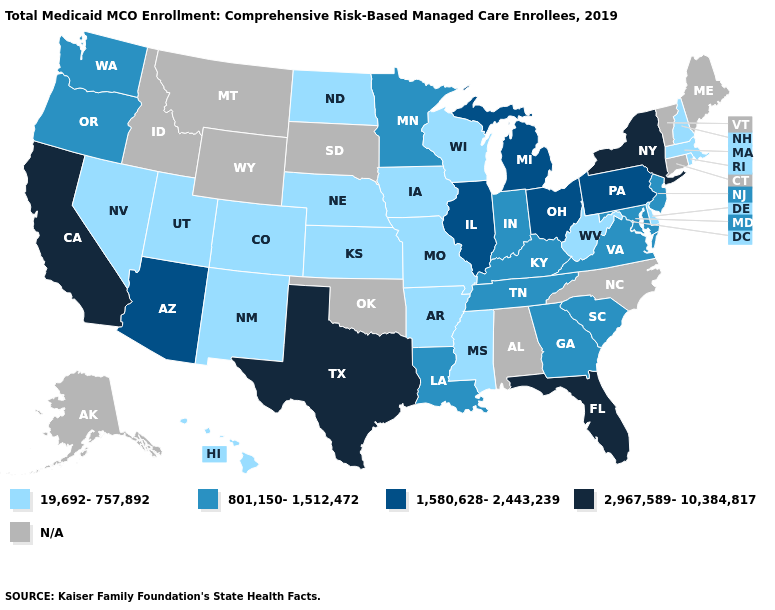Does the map have missing data?
Answer briefly. Yes. Among the states that border Montana , which have the highest value?
Answer briefly. North Dakota. Name the states that have a value in the range N/A?
Give a very brief answer. Alabama, Alaska, Connecticut, Idaho, Maine, Montana, North Carolina, Oklahoma, South Dakota, Vermont, Wyoming. Which states have the lowest value in the Northeast?
Keep it brief. Massachusetts, New Hampshire, Rhode Island. What is the value of Maine?
Concise answer only. N/A. Among the states that border Pennsylvania , which have the lowest value?
Concise answer only. Delaware, West Virginia. Does the first symbol in the legend represent the smallest category?
Be succinct. Yes. Does Colorado have the highest value in the USA?
Keep it brief. No. Does the first symbol in the legend represent the smallest category?
Short answer required. Yes. What is the highest value in the USA?
Give a very brief answer. 2,967,589-10,384,817. How many symbols are there in the legend?
Be succinct. 5. Name the states that have a value in the range 1,580,628-2,443,239?
Give a very brief answer. Arizona, Illinois, Michigan, Ohio, Pennsylvania. Does New Jersey have the lowest value in the Northeast?
Write a very short answer. No. What is the value of Alaska?
Quick response, please. N/A. Name the states that have a value in the range 801,150-1,512,472?
Short answer required. Georgia, Indiana, Kentucky, Louisiana, Maryland, Minnesota, New Jersey, Oregon, South Carolina, Tennessee, Virginia, Washington. 